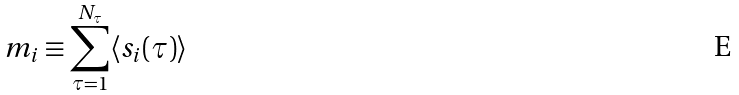Convert formula to latex. <formula><loc_0><loc_0><loc_500><loc_500>m _ { i } \equiv \sum _ { \tau = 1 } ^ { N _ { \tau } } \langle s _ { i } ( \tau ) \rangle</formula> 